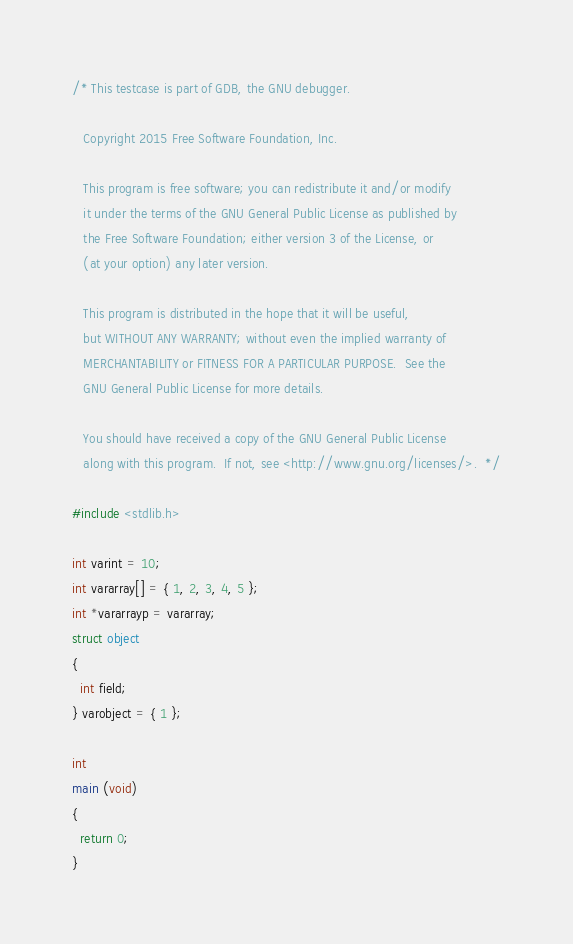<code> <loc_0><loc_0><loc_500><loc_500><_C_>/* This testcase is part of GDB, the GNU debugger.

   Copyright 2015 Free Software Foundation, Inc.

   This program is free software; you can redistribute it and/or modify
   it under the terms of the GNU General Public License as published by
   the Free Software Foundation; either version 3 of the License, or
   (at your option) any later version.

   This program is distributed in the hope that it will be useful,
   but WITHOUT ANY WARRANTY; without even the implied warranty of
   MERCHANTABILITY or FITNESS FOR A PARTICULAR PURPOSE.  See the
   GNU General Public License for more details.

   You should have received a copy of the GNU General Public License
   along with this program.  If not, see <http://www.gnu.org/licenses/>.  */

#include <stdlib.h>

int varint = 10;
int vararray[] = { 1, 2, 3, 4, 5 };
int *vararrayp = vararray;
struct object
{
  int field;
} varobject = { 1 };

int
main (void)
{
  return 0;
}
</code> 